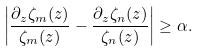Convert formula to latex. <formula><loc_0><loc_0><loc_500><loc_500>\left | \frac { \partial _ { z } \zeta _ { m } ( z ) } { \zeta _ { m } ( z ) } - \frac { \partial _ { z } \zeta _ { n } ( z ) } { \zeta _ { n } ( z ) } \right | \geq \alpha .</formula> 